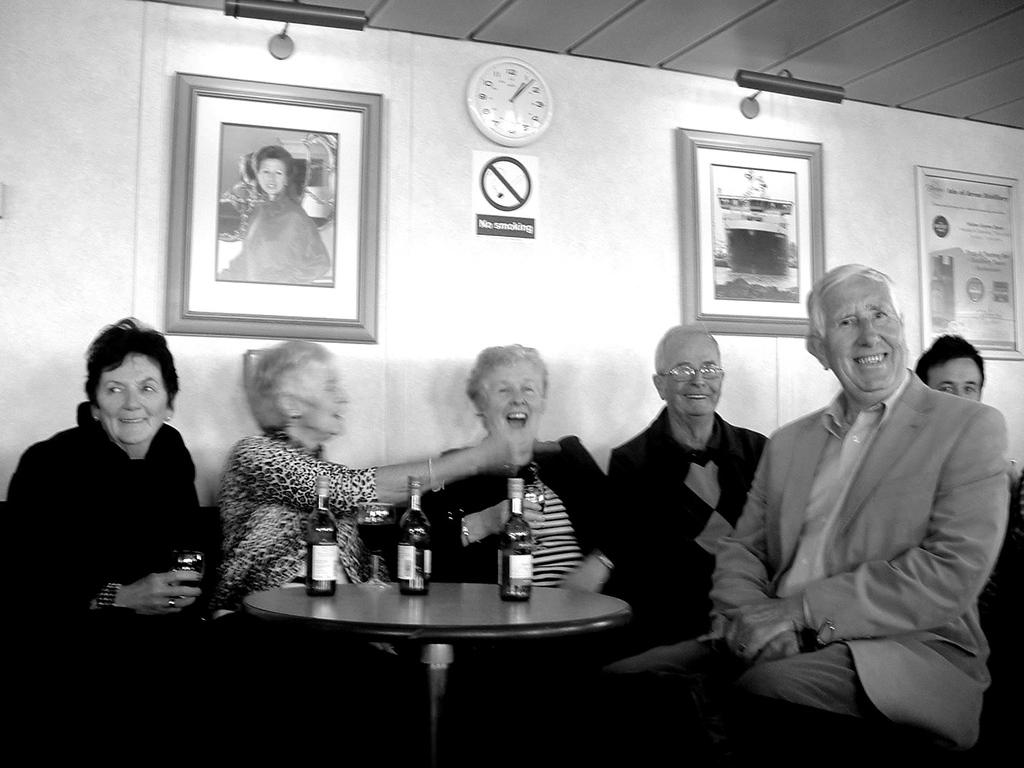What is the color scheme of the image? The image is black and white. What can be seen on the wall in the image? There are different types of pictures on the wall. What time-telling device is present on the wall? There is a clock on the wall. What are the people in the image doing? There are persons sitting on chairs and smiling. How many bottles are on the table in the image? There are three bottles on the table. What type of lace is draped over the clock in the image? There is no lace present in the image; the clock is visible without any additional decorations. 